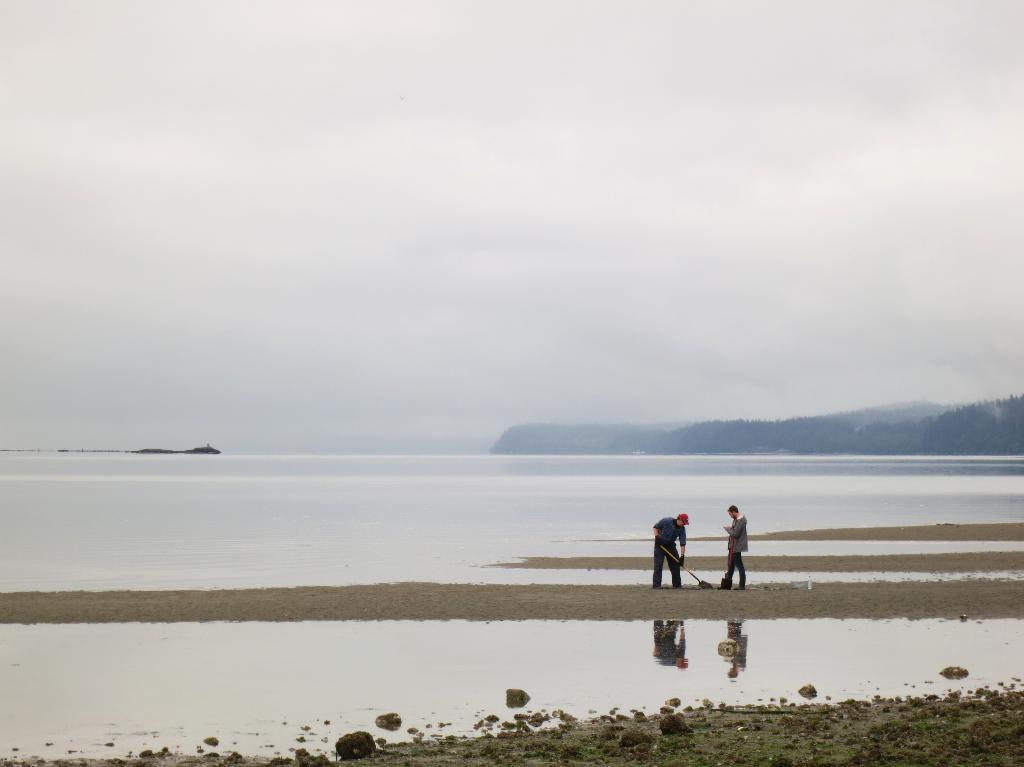Can you describe this image briefly? In the image there are standing on the land and behind its a sea, on the right side background there are trees and above its sky with clouds. 